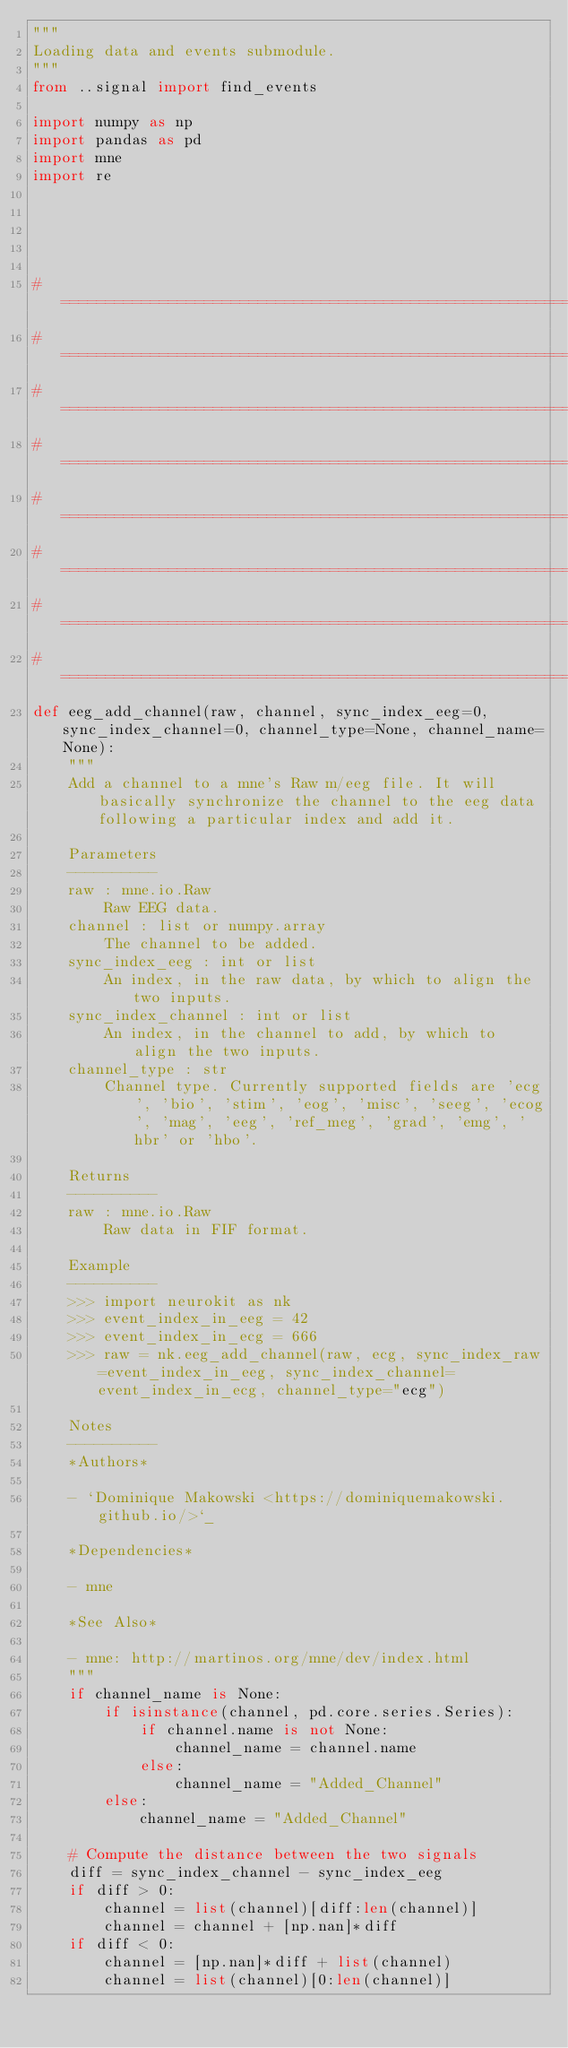<code> <loc_0><loc_0><loc_500><loc_500><_Python_>"""
Loading data and events submodule.
"""
from ..signal import find_events

import numpy as np
import pandas as pd
import mne
import re





# ==============================================================================
# ==============================================================================
# ==============================================================================
# ==============================================================================
# ==============================================================================
# ==============================================================================
# ==============================================================================
# ==============================================================================
def eeg_add_channel(raw, channel, sync_index_eeg=0, sync_index_channel=0, channel_type=None, channel_name=None):
    """
    Add a channel to a mne's Raw m/eeg file. It will basically synchronize the channel to the eeg data following a particular index and add it.

    Parameters
    ----------
    raw : mne.io.Raw
        Raw EEG data.
    channel : list or numpy.array
        The channel to be added.
    sync_index_eeg : int or list
        An index, in the raw data, by which to align the two inputs.
    sync_index_channel : int or list
        An index, in the channel to add, by which to align the two inputs.
    channel_type : str
        Channel type. Currently supported fields are 'ecg', 'bio', 'stim', 'eog', 'misc', 'seeg', 'ecog', 'mag', 'eeg', 'ref_meg', 'grad', 'emg', 'hbr' or 'hbo'.

    Returns
    ----------
    raw : mne.io.Raw
        Raw data in FIF format.

    Example
    ----------
    >>> import neurokit as nk
    >>> event_index_in_eeg = 42
    >>> event_index_in_ecg = 666
    >>> raw = nk.eeg_add_channel(raw, ecg, sync_index_raw=event_index_in_eeg, sync_index_channel=event_index_in_ecg, channel_type="ecg")

    Notes
    ----------
    *Authors*

    - `Dominique Makowski <https://dominiquemakowski.github.io/>`_

    *Dependencies*

    - mne

    *See Also*

    - mne: http://martinos.org/mne/dev/index.html
    """
    if channel_name is None:
        if isinstance(channel, pd.core.series.Series):
            if channel.name is not None:
                channel_name = channel.name
            else:
                channel_name = "Added_Channel"
        else:
            channel_name = "Added_Channel"

    # Compute the distance between the two signals
    diff = sync_index_channel - sync_index_eeg
    if diff > 0:
        channel = list(channel)[diff:len(channel)]
        channel = channel + [np.nan]*diff
    if diff < 0:
        channel = [np.nan]*diff + list(channel)
        channel = list(channel)[0:len(channel)]
</code> 